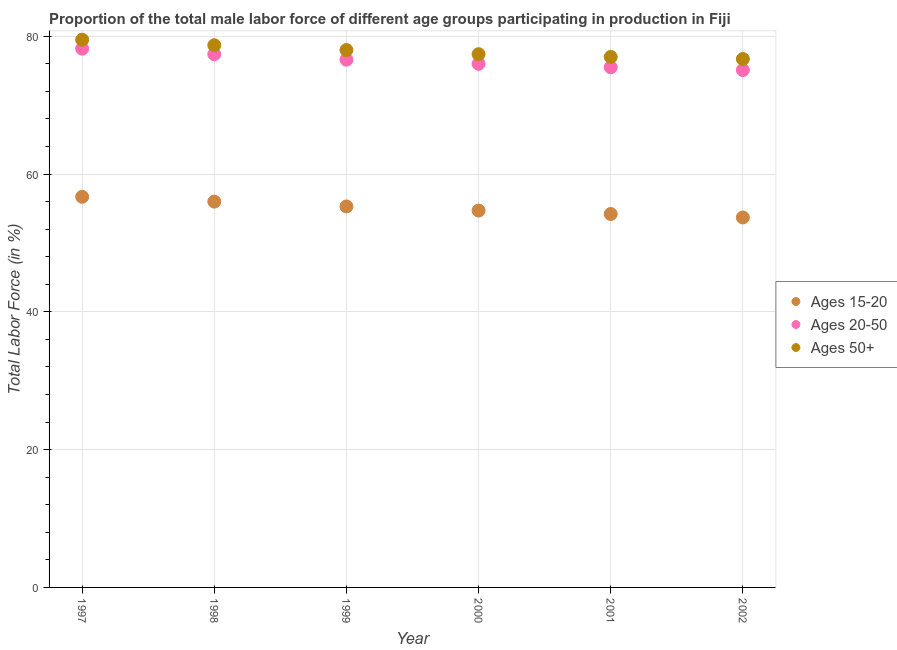How many different coloured dotlines are there?
Keep it short and to the point. 3. Is the number of dotlines equal to the number of legend labels?
Ensure brevity in your answer.  Yes. What is the percentage of male labor force within the age group 20-50 in 2001?
Provide a short and direct response. 75.5. Across all years, what is the maximum percentage of male labor force above age 50?
Keep it short and to the point. 79.5. Across all years, what is the minimum percentage of male labor force within the age group 20-50?
Make the answer very short. 75.1. What is the total percentage of male labor force within the age group 20-50 in the graph?
Give a very brief answer. 458.8. What is the difference between the percentage of male labor force within the age group 15-20 in 2000 and that in 2001?
Your response must be concise. 0.5. What is the difference between the percentage of male labor force above age 50 in 1997 and the percentage of male labor force within the age group 15-20 in 2002?
Ensure brevity in your answer.  25.8. What is the average percentage of male labor force within the age group 15-20 per year?
Keep it short and to the point. 55.1. In the year 1998, what is the difference between the percentage of male labor force within the age group 15-20 and percentage of male labor force above age 50?
Offer a terse response. -22.7. In how many years, is the percentage of male labor force above age 50 greater than 24 %?
Offer a very short reply. 6. What is the ratio of the percentage of male labor force within the age group 15-20 in 1998 to that in 2000?
Keep it short and to the point. 1.02. Is the percentage of male labor force above age 50 in 2000 less than that in 2001?
Make the answer very short. No. What is the difference between the highest and the second highest percentage of male labor force within the age group 20-50?
Offer a terse response. 0.8. What is the difference between the highest and the lowest percentage of male labor force above age 50?
Ensure brevity in your answer.  2.8. In how many years, is the percentage of male labor force above age 50 greater than the average percentage of male labor force above age 50 taken over all years?
Provide a short and direct response. 3. Is the sum of the percentage of male labor force within the age group 15-20 in 1999 and 2001 greater than the maximum percentage of male labor force above age 50 across all years?
Provide a short and direct response. Yes. Does the percentage of male labor force within the age group 15-20 monotonically increase over the years?
Offer a terse response. No. How many years are there in the graph?
Offer a very short reply. 6. Are the values on the major ticks of Y-axis written in scientific E-notation?
Make the answer very short. No. Does the graph contain any zero values?
Offer a terse response. No. Does the graph contain grids?
Offer a very short reply. Yes. How many legend labels are there?
Offer a terse response. 3. What is the title of the graph?
Ensure brevity in your answer.  Proportion of the total male labor force of different age groups participating in production in Fiji. What is the label or title of the Y-axis?
Give a very brief answer. Total Labor Force (in %). What is the Total Labor Force (in %) of Ages 15-20 in 1997?
Give a very brief answer. 56.7. What is the Total Labor Force (in %) in Ages 20-50 in 1997?
Keep it short and to the point. 78.2. What is the Total Labor Force (in %) in Ages 50+ in 1997?
Your response must be concise. 79.5. What is the Total Labor Force (in %) in Ages 20-50 in 1998?
Provide a succinct answer. 77.4. What is the Total Labor Force (in %) of Ages 50+ in 1998?
Your answer should be compact. 78.7. What is the Total Labor Force (in %) of Ages 15-20 in 1999?
Offer a very short reply. 55.3. What is the Total Labor Force (in %) in Ages 20-50 in 1999?
Keep it short and to the point. 76.6. What is the Total Labor Force (in %) in Ages 50+ in 1999?
Your answer should be very brief. 78. What is the Total Labor Force (in %) of Ages 15-20 in 2000?
Make the answer very short. 54.7. What is the Total Labor Force (in %) of Ages 50+ in 2000?
Your answer should be compact. 77.4. What is the Total Labor Force (in %) of Ages 15-20 in 2001?
Ensure brevity in your answer.  54.2. What is the Total Labor Force (in %) in Ages 20-50 in 2001?
Your response must be concise. 75.5. What is the Total Labor Force (in %) in Ages 50+ in 2001?
Keep it short and to the point. 77. What is the Total Labor Force (in %) in Ages 15-20 in 2002?
Your response must be concise. 53.7. What is the Total Labor Force (in %) of Ages 20-50 in 2002?
Your answer should be very brief. 75.1. What is the Total Labor Force (in %) in Ages 50+ in 2002?
Your answer should be very brief. 76.7. Across all years, what is the maximum Total Labor Force (in %) in Ages 15-20?
Offer a terse response. 56.7. Across all years, what is the maximum Total Labor Force (in %) of Ages 20-50?
Keep it short and to the point. 78.2. Across all years, what is the maximum Total Labor Force (in %) of Ages 50+?
Give a very brief answer. 79.5. Across all years, what is the minimum Total Labor Force (in %) in Ages 15-20?
Your answer should be very brief. 53.7. Across all years, what is the minimum Total Labor Force (in %) in Ages 20-50?
Provide a succinct answer. 75.1. Across all years, what is the minimum Total Labor Force (in %) of Ages 50+?
Provide a succinct answer. 76.7. What is the total Total Labor Force (in %) of Ages 15-20 in the graph?
Provide a short and direct response. 330.6. What is the total Total Labor Force (in %) of Ages 20-50 in the graph?
Give a very brief answer. 458.8. What is the total Total Labor Force (in %) of Ages 50+ in the graph?
Keep it short and to the point. 467.3. What is the difference between the Total Labor Force (in %) of Ages 20-50 in 1997 and that in 1998?
Give a very brief answer. 0.8. What is the difference between the Total Labor Force (in %) in Ages 50+ in 1997 and that in 1999?
Provide a short and direct response. 1.5. What is the difference between the Total Labor Force (in %) of Ages 50+ in 1997 and that in 2000?
Give a very brief answer. 2.1. What is the difference between the Total Labor Force (in %) of Ages 15-20 in 1997 and that in 2001?
Your response must be concise. 2.5. What is the difference between the Total Labor Force (in %) of Ages 20-50 in 1997 and that in 2001?
Offer a very short reply. 2.7. What is the difference between the Total Labor Force (in %) in Ages 50+ in 1997 and that in 2001?
Keep it short and to the point. 2.5. What is the difference between the Total Labor Force (in %) of Ages 15-20 in 1997 and that in 2002?
Offer a very short reply. 3. What is the difference between the Total Labor Force (in %) in Ages 20-50 in 1997 and that in 2002?
Make the answer very short. 3.1. What is the difference between the Total Labor Force (in %) of Ages 50+ in 1997 and that in 2002?
Your answer should be very brief. 2.8. What is the difference between the Total Labor Force (in %) of Ages 15-20 in 1998 and that in 1999?
Your answer should be compact. 0.7. What is the difference between the Total Labor Force (in %) in Ages 20-50 in 1998 and that in 1999?
Your response must be concise. 0.8. What is the difference between the Total Labor Force (in %) in Ages 15-20 in 1998 and that in 2001?
Offer a terse response. 1.8. What is the difference between the Total Labor Force (in %) in Ages 15-20 in 1999 and that in 2001?
Provide a succinct answer. 1.1. What is the difference between the Total Labor Force (in %) in Ages 15-20 in 1999 and that in 2002?
Keep it short and to the point. 1.6. What is the difference between the Total Labor Force (in %) of Ages 20-50 in 1999 and that in 2002?
Provide a succinct answer. 1.5. What is the difference between the Total Labor Force (in %) of Ages 50+ in 1999 and that in 2002?
Offer a terse response. 1.3. What is the difference between the Total Labor Force (in %) of Ages 50+ in 2000 and that in 2001?
Offer a terse response. 0.4. What is the difference between the Total Labor Force (in %) of Ages 15-20 in 2000 and that in 2002?
Give a very brief answer. 1. What is the difference between the Total Labor Force (in %) of Ages 50+ in 2000 and that in 2002?
Give a very brief answer. 0.7. What is the difference between the Total Labor Force (in %) of Ages 15-20 in 2001 and that in 2002?
Ensure brevity in your answer.  0.5. What is the difference between the Total Labor Force (in %) in Ages 20-50 in 2001 and that in 2002?
Offer a terse response. 0.4. What is the difference between the Total Labor Force (in %) of Ages 50+ in 2001 and that in 2002?
Your response must be concise. 0.3. What is the difference between the Total Labor Force (in %) of Ages 15-20 in 1997 and the Total Labor Force (in %) of Ages 20-50 in 1998?
Your response must be concise. -20.7. What is the difference between the Total Labor Force (in %) in Ages 15-20 in 1997 and the Total Labor Force (in %) in Ages 50+ in 1998?
Make the answer very short. -22. What is the difference between the Total Labor Force (in %) in Ages 20-50 in 1997 and the Total Labor Force (in %) in Ages 50+ in 1998?
Make the answer very short. -0.5. What is the difference between the Total Labor Force (in %) of Ages 15-20 in 1997 and the Total Labor Force (in %) of Ages 20-50 in 1999?
Provide a succinct answer. -19.9. What is the difference between the Total Labor Force (in %) in Ages 15-20 in 1997 and the Total Labor Force (in %) in Ages 50+ in 1999?
Offer a very short reply. -21.3. What is the difference between the Total Labor Force (in %) in Ages 15-20 in 1997 and the Total Labor Force (in %) in Ages 20-50 in 2000?
Provide a short and direct response. -19.3. What is the difference between the Total Labor Force (in %) in Ages 15-20 in 1997 and the Total Labor Force (in %) in Ages 50+ in 2000?
Offer a terse response. -20.7. What is the difference between the Total Labor Force (in %) in Ages 20-50 in 1997 and the Total Labor Force (in %) in Ages 50+ in 2000?
Offer a terse response. 0.8. What is the difference between the Total Labor Force (in %) of Ages 15-20 in 1997 and the Total Labor Force (in %) of Ages 20-50 in 2001?
Make the answer very short. -18.8. What is the difference between the Total Labor Force (in %) in Ages 15-20 in 1997 and the Total Labor Force (in %) in Ages 50+ in 2001?
Give a very brief answer. -20.3. What is the difference between the Total Labor Force (in %) in Ages 15-20 in 1997 and the Total Labor Force (in %) in Ages 20-50 in 2002?
Keep it short and to the point. -18.4. What is the difference between the Total Labor Force (in %) in Ages 15-20 in 1998 and the Total Labor Force (in %) in Ages 20-50 in 1999?
Offer a terse response. -20.6. What is the difference between the Total Labor Force (in %) of Ages 15-20 in 1998 and the Total Labor Force (in %) of Ages 50+ in 1999?
Give a very brief answer. -22. What is the difference between the Total Labor Force (in %) in Ages 15-20 in 1998 and the Total Labor Force (in %) in Ages 50+ in 2000?
Your answer should be compact. -21.4. What is the difference between the Total Labor Force (in %) in Ages 15-20 in 1998 and the Total Labor Force (in %) in Ages 20-50 in 2001?
Give a very brief answer. -19.5. What is the difference between the Total Labor Force (in %) of Ages 15-20 in 1998 and the Total Labor Force (in %) of Ages 50+ in 2001?
Your answer should be compact. -21. What is the difference between the Total Labor Force (in %) in Ages 15-20 in 1998 and the Total Labor Force (in %) in Ages 20-50 in 2002?
Your answer should be compact. -19.1. What is the difference between the Total Labor Force (in %) in Ages 15-20 in 1998 and the Total Labor Force (in %) in Ages 50+ in 2002?
Your answer should be very brief. -20.7. What is the difference between the Total Labor Force (in %) of Ages 20-50 in 1998 and the Total Labor Force (in %) of Ages 50+ in 2002?
Make the answer very short. 0.7. What is the difference between the Total Labor Force (in %) of Ages 15-20 in 1999 and the Total Labor Force (in %) of Ages 20-50 in 2000?
Keep it short and to the point. -20.7. What is the difference between the Total Labor Force (in %) in Ages 15-20 in 1999 and the Total Labor Force (in %) in Ages 50+ in 2000?
Provide a short and direct response. -22.1. What is the difference between the Total Labor Force (in %) of Ages 20-50 in 1999 and the Total Labor Force (in %) of Ages 50+ in 2000?
Your response must be concise. -0.8. What is the difference between the Total Labor Force (in %) in Ages 15-20 in 1999 and the Total Labor Force (in %) in Ages 20-50 in 2001?
Your response must be concise. -20.2. What is the difference between the Total Labor Force (in %) of Ages 15-20 in 1999 and the Total Labor Force (in %) of Ages 50+ in 2001?
Give a very brief answer. -21.7. What is the difference between the Total Labor Force (in %) in Ages 15-20 in 1999 and the Total Labor Force (in %) in Ages 20-50 in 2002?
Keep it short and to the point. -19.8. What is the difference between the Total Labor Force (in %) of Ages 15-20 in 1999 and the Total Labor Force (in %) of Ages 50+ in 2002?
Your answer should be compact. -21.4. What is the difference between the Total Labor Force (in %) of Ages 20-50 in 1999 and the Total Labor Force (in %) of Ages 50+ in 2002?
Your response must be concise. -0.1. What is the difference between the Total Labor Force (in %) in Ages 15-20 in 2000 and the Total Labor Force (in %) in Ages 20-50 in 2001?
Provide a succinct answer. -20.8. What is the difference between the Total Labor Force (in %) of Ages 15-20 in 2000 and the Total Labor Force (in %) of Ages 50+ in 2001?
Provide a succinct answer. -22.3. What is the difference between the Total Labor Force (in %) in Ages 20-50 in 2000 and the Total Labor Force (in %) in Ages 50+ in 2001?
Give a very brief answer. -1. What is the difference between the Total Labor Force (in %) of Ages 15-20 in 2000 and the Total Labor Force (in %) of Ages 20-50 in 2002?
Make the answer very short. -20.4. What is the difference between the Total Labor Force (in %) in Ages 15-20 in 2001 and the Total Labor Force (in %) in Ages 20-50 in 2002?
Offer a very short reply. -20.9. What is the difference between the Total Labor Force (in %) of Ages 15-20 in 2001 and the Total Labor Force (in %) of Ages 50+ in 2002?
Give a very brief answer. -22.5. What is the difference between the Total Labor Force (in %) of Ages 20-50 in 2001 and the Total Labor Force (in %) of Ages 50+ in 2002?
Your answer should be compact. -1.2. What is the average Total Labor Force (in %) in Ages 15-20 per year?
Offer a very short reply. 55.1. What is the average Total Labor Force (in %) in Ages 20-50 per year?
Your answer should be very brief. 76.47. What is the average Total Labor Force (in %) of Ages 50+ per year?
Make the answer very short. 77.88. In the year 1997, what is the difference between the Total Labor Force (in %) of Ages 15-20 and Total Labor Force (in %) of Ages 20-50?
Ensure brevity in your answer.  -21.5. In the year 1997, what is the difference between the Total Labor Force (in %) of Ages 15-20 and Total Labor Force (in %) of Ages 50+?
Make the answer very short. -22.8. In the year 1997, what is the difference between the Total Labor Force (in %) in Ages 20-50 and Total Labor Force (in %) in Ages 50+?
Your answer should be compact. -1.3. In the year 1998, what is the difference between the Total Labor Force (in %) in Ages 15-20 and Total Labor Force (in %) in Ages 20-50?
Offer a very short reply. -21.4. In the year 1998, what is the difference between the Total Labor Force (in %) of Ages 15-20 and Total Labor Force (in %) of Ages 50+?
Your answer should be compact. -22.7. In the year 1998, what is the difference between the Total Labor Force (in %) in Ages 20-50 and Total Labor Force (in %) in Ages 50+?
Make the answer very short. -1.3. In the year 1999, what is the difference between the Total Labor Force (in %) in Ages 15-20 and Total Labor Force (in %) in Ages 20-50?
Offer a terse response. -21.3. In the year 1999, what is the difference between the Total Labor Force (in %) in Ages 15-20 and Total Labor Force (in %) in Ages 50+?
Your answer should be compact. -22.7. In the year 2000, what is the difference between the Total Labor Force (in %) of Ages 15-20 and Total Labor Force (in %) of Ages 20-50?
Keep it short and to the point. -21.3. In the year 2000, what is the difference between the Total Labor Force (in %) of Ages 15-20 and Total Labor Force (in %) of Ages 50+?
Your response must be concise. -22.7. In the year 2001, what is the difference between the Total Labor Force (in %) of Ages 15-20 and Total Labor Force (in %) of Ages 20-50?
Your response must be concise. -21.3. In the year 2001, what is the difference between the Total Labor Force (in %) of Ages 15-20 and Total Labor Force (in %) of Ages 50+?
Offer a very short reply. -22.8. In the year 2001, what is the difference between the Total Labor Force (in %) in Ages 20-50 and Total Labor Force (in %) in Ages 50+?
Provide a succinct answer. -1.5. In the year 2002, what is the difference between the Total Labor Force (in %) of Ages 15-20 and Total Labor Force (in %) of Ages 20-50?
Give a very brief answer. -21.4. In the year 2002, what is the difference between the Total Labor Force (in %) of Ages 15-20 and Total Labor Force (in %) of Ages 50+?
Offer a terse response. -23. In the year 2002, what is the difference between the Total Labor Force (in %) of Ages 20-50 and Total Labor Force (in %) of Ages 50+?
Your answer should be compact. -1.6. What is the ratio of the Total Labor Force (in %) in Ages 15-20 in 1997 to that in 1998?
Offer a very short reply. 1.01. What is the ratio of the Total Labor Force (in %) in Ages 20-50 in 1997 to that in 1998?
Make the answer very short. 1.01. What is the ratio of the Total Labor Force (in %) in Ages 50+ in 1997 to that in 1998?
Provide a short and direct response. 1.01. What is the ratio of the Total Labor Force (in %) of Ages 15-20 in 1997 to that in 1999?
Provide a succinct answer. 1.03. What is the ratio of the Total Labor Force (in %) in Ages 20-50 in 1997 to that in 1999?
Provide a succinct answer. 1.02. What is the ratio of the Total Labor Force (in %) of Ages 50+ in 1997 to that in 1999?
Your response must be concise. 1.02. What is the ratio of the Total Labor Force (in %) in Ages 15-20 in 1997 to that in 2000?
Your response must be concise. 1.04. What is the ratio of the Total Labor Force (in %) of Ages 20-50 in 1997 to that in 2000?
Offer a very short reply. 1.03. What is the ratio of the Total Labor Force (in %) in Ages 50+ in 1997 to that in 2000?
Make the answer very short. 1.03. What is the ratio of the Total Labor Force (in %) of Ages 15-20 in 1997 to that in 2001?
Your response must be concise. 1.05. What is the ratio of the Total Labor Force (in %) in Ages 20-50 in 1997 to that in 2001?
Give a very brief answer. 1.04. What is the ratio of the Total Labor Force (in %) of Ages 50+ in 1997 to that in 2001?
Provide a short and direct response. 1.03. What is the ratio of the Total Labor Force (in %) of Ages 15-20 in 1997 to that in 2002?
Give a very brief answer. 1.06. What is the ratio of the Total Labor Force (in %) of Ages 20-50 in 1997 to that in 2002?
Your answer should be compact. 1.04. What is the ratio of the Total Labor Force (in %) of Ages 50+ in 1997 to that in 2002?
Provide a short and direct response. 1.04. What is the ratio of the Total Labor Force (in %) in Ages 15-20 in 1998 to that in 1999?
Make the answer very short. 1.01. What is the ratio of the Total Labor Force (in %) of Ages 20-50 in 1998 to that in 1999?
Your answer should be compact. 1.01. What is the ratio of the Total Labor Force (in %) in Ages 15-20 in 1998 to that in 2000?
Your response must be concise. 1.02. What is the ratio of the Total Labor Force (in %) in Ages 20-50 in 1998 to that in 2000?
Give a very brief answer. 1.02. What is the ratio of the Total Labor Force (in %) of Ages 50+ in 1998 to that in 2000?
Give a very brief answer. 1.02. What is the ratio of the Total Labor Force (in %) of Ages 15-20 in 1998 to that in 2001?
Ensure brevity in your answer.  1.03. What is the ratio of the Total Labor Force (in %) of Ages 20-50 in 1998 to that in 2001?
Offer a terse response. 1.03. What is the ratio of the Total Labor Force (in %) of Ages 50+ in 1998 to that in 2001?
Ensure brevity in your answer.  1.02. What is the ratio of the Total Labor Force (in %) in Ages 15-20 in 1998 to that in 2002?
Give a very brief answer. 1.04. What is the ratio of the Total Labor Force (in %) of Ages 20-50 in 1998 to that in 2002?
Offer a terse response. 1.03. What is the ratio of the Total Labor Force (in %) in Ages 50+ in 1998 to that in 2002?
Provide a succinct answer. 1.03. What is the ratio of the Total Labor Force (in %) of Ages 15-20 in 1999 to that in 2000?
Offer a very short reply. 1.01. What is the ratio of the Total Labor Force (in %) in Ages 20-50 in 1999 to that in 2000?
Make the answer very short. 1.01. What is the ratio of the Total Labor Force (in %) in Ages 50+ in 1999 to that in 2000?
Offer a terse response. 1.01. What is the ratio of the Total Labor Force (in %) in Ages 15-20 in 1999 to that in 2001?
Make the answer very short. 1.02. What is the ratio of the Total Labor Force (in %) in Ages 20-50 in 1999 to that in 2001?
Your answer should be compact. 1.01. What is the ratio of the Total Labor Force (in %) of Ages 15-20 in 1999 to that in 2002?
Your answer should be very brief. 1.03. What is the ratio of the Total Labor Force (in %) in Ages 20-50 in 1999 to that in 2002?
Your answer should be compact. 1.02. What is the ratio of the Total Labor Force (in %) in Ages 50+ in 1999 to that in 2002?
Ensure brevity in your answer.  1.02. What is the ratio of the Total Labor Force (in %) in Ages 15-20 in 2000 to that in 2001?
Offer a terse response. 1.01. What is the ratio of the Total Labor Force (in %) of Ages 20-50 in 2000 to that in 2001?
Keep it short and to the point. 1.01. What is the ratio of the Total Labor Force (in %) of Ages 50+ in 2000 to that in 2001?
Make the answer very short. 1.01. What is the ratio of the Total Labor Force (in %) of Ages 15-20 in 2000 to that in 2002?
Keep it short and to the point. 1.02. What is the ratio of the Total Labor Force (in %) of Ages 20-50 in 2000 to that in 2002?
Make the answer very short. 1.01. What is the ratio of the Total Labor Force (in %) in Ages 50+ in 2000 to that in 2002?
Offer a terse response. 1.01. What is the ratio of the Total Labor Force (in %) of Ages 15-20 in 2001 to that in 2002?
Provide a short and direct response. 1.01. What is the ratio of the Total Labor Force (in %) of Ages 20-50 in 2001 to that in 2002?
Keep it short and to the point. 1.01. What is the ratio of the Total Labor Force (in %) in Ages 50+ in 2001 to that in 2002?
Keep it short and to the point. 1. What is the difference between the highest and the lowest Total Labor Force (in %) of Ages 20-50?
Give a very brief answer. 3.1. 